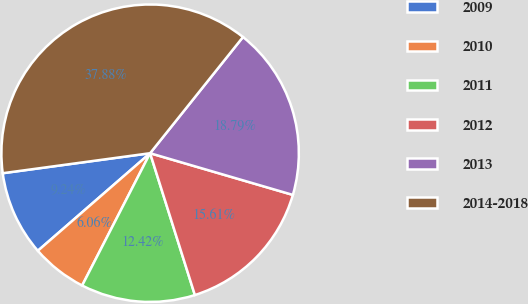Convert chart. <chart><loc_0><loc_0><loc_500><loc_500><pie_chart><fcel>2009<fcel>2010<fcel>2011<fcel>2012<fcel>2013<fcel>2014-2018<nl><fcel>9.24%<fcel>6.06%<fcel>12.42%<fcel>15.61%<fcel>18.79%<fcel>37.88%<nl></chart> 